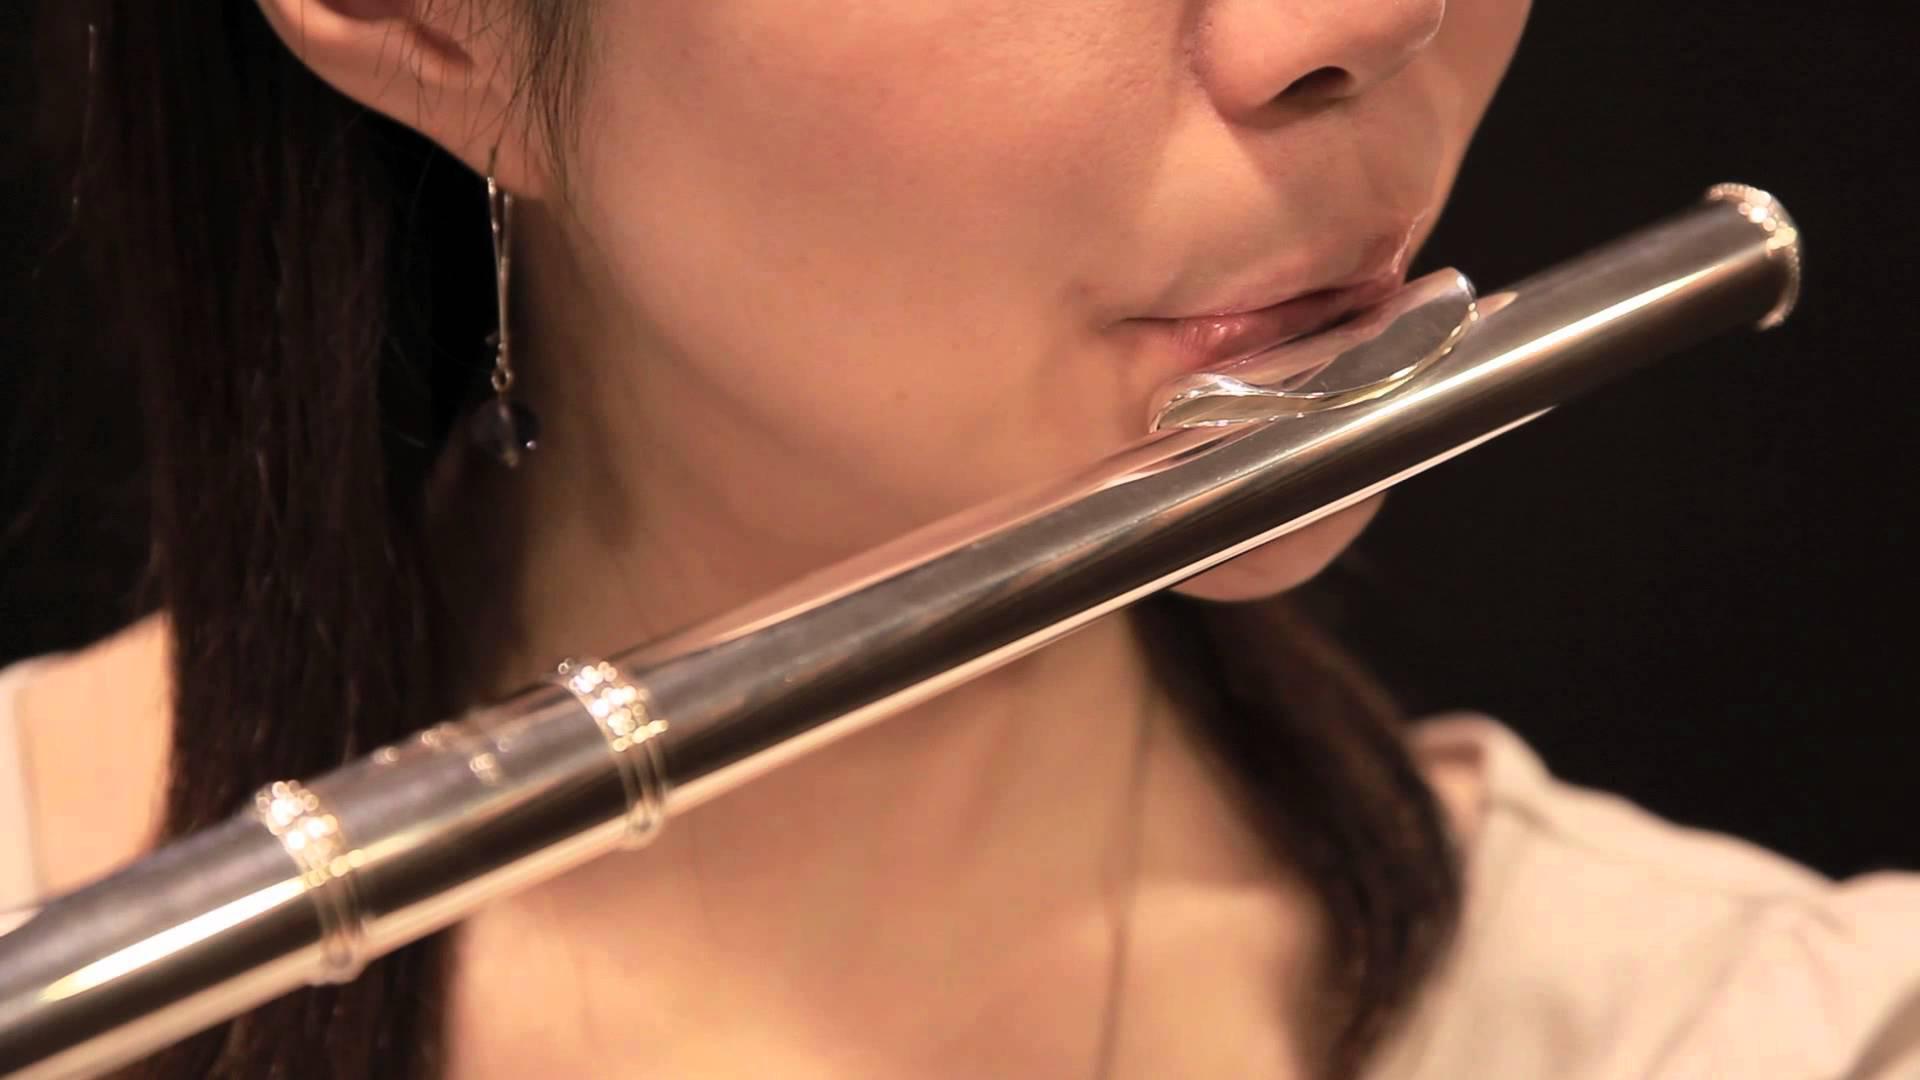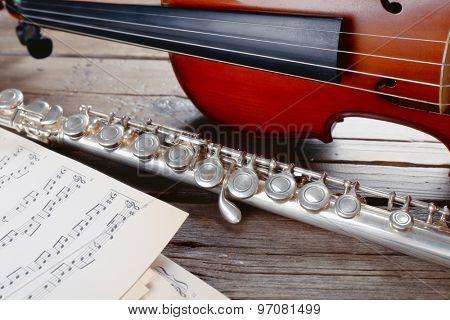The first image is the image on the left, the second image is the image on the right. Evaluate the accuracy of this statement regarding the images: "The left image shows a trio of musicians on a stage, with the person on the far left standing playing a wind instrument and the person on the far right sitting playing a string instrument.". Is it true? Answer yes or no. No. The first image is the image on the left, the second image is the image on the right. Given the left and right images, does the statement "The left image contains three humans on a stage playing musical instruments." hold true? Answer yes or no. No. 